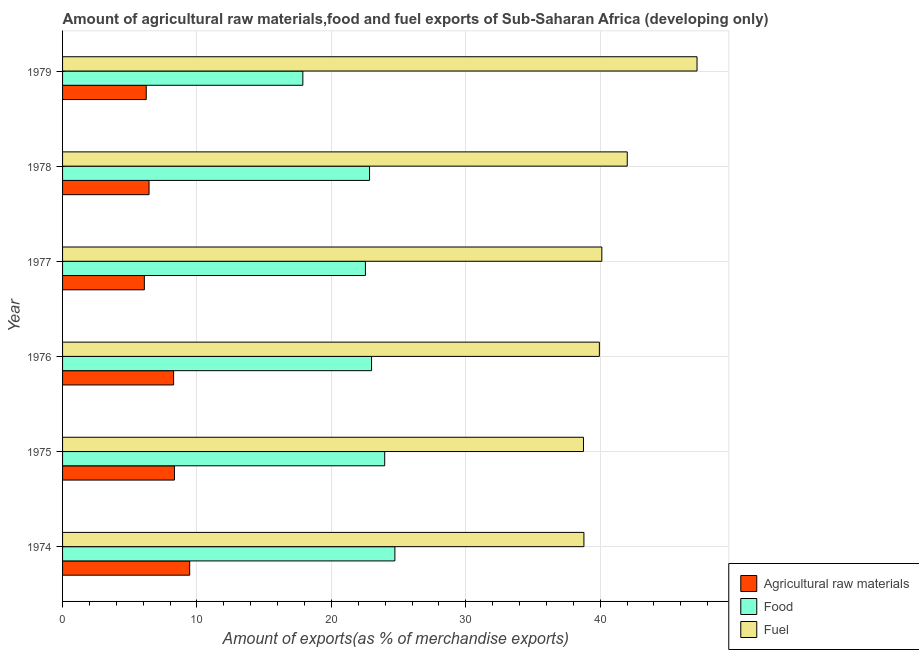How many groups of bars are there?
Your answer should be very brief. 6. Are the number of bars on each tick of the Y-axis equal?
Provide a short and direct response. Yes. How many bars are there on the 1st tick from the top?
Offer a very short reply. 3. What is the label of the 2nd group of bars from the top?
Offer a very short reply. 1978. In how many cases, is the number of bars for a given year not equal to the number of legend labels?
Your answer should be compact. 0. What is the percentage of raw materials exports in 1977?
Make the answer very short. 6.09. Across all years, what is the maximum percentage of raw materials exports?
Your response must be concise. 9.46. Across all years, what is the minimum percentage of raw materials exports?
Keep it short and to the point. 6.09. In which year was the percentage of raw materials exports maximum?
Keep it short and to the point. 1974. In which year was the percentage of food exports minimum?
Your answer should be very brief. 1979. What is the total percentage of food exports in the graph?
Make the answer very short. 134.93. What is the difference between the percentage of raw materials exports in 1976 and that in 1978?
Your answer should be very brief. 1.83. What is the difference between the percentage of food exports in 1979 and the percentage of fuel exports in 1977?
Make the answer very short. -22.24. What is the average percentage of food exports per year?
Your answer should be very brief. 22.49. In the year 1976, what is the difference between the percentage of fuel exports and percentage of food exports?
Offer a very short reply. 16.95. What is the ratio of the percentage of food exports in 1976 to that in 1977?
Make the answer very short. 1.02. Is the percentage of food exports in 1976 less than that in 1978?
Keep it short and to the point. No. What is the difference between the highest and the second highest percentage of food exports?
Offer a terse response. 0.76. What is the difference between the highest and the lowest percentage of fuel exports?
Ensure brevity in your answer.  8.45. In how many years, is the percentage of raw materials exports greater than the average percentage of raw materials exports taken over all years?
Your answer should be very brief. 3. Is the sum of the percentage of raw materials exports in 1978 and 1979 greater than the maximum percentage of food exports across all years?
Your answer should be very brief. No. What does the 1st bar from the top in 1977 represents?
Provide a short and direct response. Fuel. What does the 2nd bar from the bottom in 1976 represents?
Your answer should be very brief. Food. Is it the case that in every year, the sum of the percentage of raw materials exports and percentage of food exports is greater than the percentage of fuel exports?
Provide a short and direct response. No. How many bars are there?
Provide a succinct answer. 18. How many years are there in the graph?
Ensure brevity in your answer.  6. Are the values on the major ticks of X-axis written in scientific E-notation?
Your answer should be very brief. No. Does the graph contain grids?
Offer a very short reply. Yes. Where does the legend appear in the graph?
Provide a short and direct response. Bottom right. How many legend labels are there?
Give a very brief answer. 3. What is the title of the graph?
Keep it short and to the point. Amount of agricultural raw materials,food and fuel exports of Sub-Saharan Africa (developing only). What is the label or title of the X-axis?
Keep it short and to the point. Amount of exports(as % of merchandise exports). What is the Amount of exports(as % of merchandise exports) in Agricultural raw materials in 1974?
Give a very brief answer. 9.46. What is the Amount of exports(as % of merchandise exports) of Food in 1974?
Your response must be concise. 24.72. What is the Amount of exports(as % of merchandise exports) of Fuel in 1974?
Your answer should be compact. 38.79. What is the Amount of exports(as % of merchandise exports) of Agricultural raw materials in 1975?
Your answer should be very brief. 8.33. What is the Amount of exports(as % of merchandise exports) in Food in 1975?
Your response must be concise. 23.97. What is the Amount of exports(as % of merchandise exports) of Fuel in 1975?
Your answer should be very brief. 38.75. What is the Amount of exports(as % of merchandise exports) in Agricultural raw materials in 1976?
Offer a very short reply. 8.26. What is the Amount of exports(as % of merchandise exports) of Food in 1976?
Your answer should be compact. 22.99. What is the Amount of exports(as % of merchandise exports) of Fuel in 1976?
Offer a very short reply. 39.94. What is the Amount of exports(as % of merchandise exports) in Agricultural raw materials in 1977?
Your answer should be very brief. 6.09. What is the Amount of exports(as % of merchandise exports) in Food in 1977?
Ensure brevity in your answer.  22.53. What is the Amount of exports(as % of merchandise exports) in Fuel in 1977?
Provide a succinct answer. 40.12. What is the Amount of exports(as % of merchandise exports) in Agricultural raw materials in 1978?
Keep it short and to the point. 6.43. What is the Amount of exports(as % of merchandise exports) in Food in 1978?
Provide a short and direct response. 22.84. What is the Amount of exports(as % of merchandise exports) in Fuel in 1978?
Your answer should be very brief. 42.01. What is the Amount of exports(as % of merchandise exports) of Agricultural raw materials in 1979?
Your answer should be compact. 6.23. What is the Amount of exports(as % of merchandise exports) in Food in 1979?
Offer a very short reply. 17.88. What is the Amount of exports(as % of merchandise exports) of Fuel in 1979?
Your response must be concise. 47.2. Across all years, what is the maximum Amount of exports(as % of merchandise exports) of Agricultural raw materials?
Keep it short and to the point. 9.46. Across all years, what is the maximum Amount of exports(as % of merchandise exports) in Food?
Ensure brevity in your answer.  24.72. Across all years, what is the maximum Amount of exports(as % of merchandise exports) in Fuel?
Keep it short and to the point. 47.2. Across all years, what is the minimum Amount of exports(as % of merchandise exports) in Agricultural raw materials?
Your response must be concise. 6.09. Across all years, what is the minimum Amount of exports(as % of merchandise exports) in Food?
Keep it short and to the point. 17.88. Across all years, what is the minimum Amount of exports(as % of merchandise exports) of Fuel?
Your answer should be compact. 38.75. What is the total Amount of exports(as % of merchandise exports) in Agricultural raw materials in the graph?
Your answer should be compact. 44.79. What is the total Amount of exports(as % of merchandise exports) of Food in the graph?
Give a very brief answer. 134.93. What is the total Amount of exports(as % of merchandise exports) of Fuel in the graph?
Offer a terse response. 246.82. What is the difference between the Amount of exports(as % of merchandise exports) in Agricultural raw materials in 1974 and that in 1975?
Your answer should be very brief. 1.13. What is the difference between the Amount of exports(as % of merchandise exports) in Food in 1974 and that in 1975?
Make the answer very short. 0.76. What is the difference between the Amount of exports(as % of merchandise exports) in Fuel in 1974 and that in 1975?
Ensure brevity in your answer.  0.03. What is the difference between the Amount of exports(as % of merchandise exports) in Agricultural raw materials in 1974 and that in 1976?
Give a very brief answer. 1.2. What is the difference between the Amount of exports(as % of merchandise exports) in Food in 1974 and that in 1976?
Your response must be concise. 1.74. What is the difference between the Amount of exports(as % of merchandise exports) in Fuel in 1974 and that in 1976?
Offer a terse response. -1.15. What is the difference between the Amount of exports(as % of merchandise exports) of Agricultural raw materials in 1974 and that in 1977?
Offer a very short reply. 3.37. What is the difference between the Amount of exports(as % of merchandise exports) of Food in 1974 and that in 1977?
Keep it short and to the point. 2.19. What is the difference between the Amount of exports(as % of merchandise exports) in Fuel in 1974 and that in 1977?
Your answer should be compact. -1.33. What is the difference between the Amount of exports(as % of merchandise exports) in Agricultural raw materials in 1974 and that in 1978?
Make the answer very short. 3.02. What is the difference between the Amount of exports(as % of merchandise exports) of Food in 1974 and that in 1978?
Give a very brief answer. 1.89. What is the difference between the Amount of exports(as % of merchandise exports) of Fuel in 1974 and that in 1978?
Ensure brevity in your answer.  -3.22. What is the difference between the Amount of exports(as % of merchandise exports) of Agricultural raw materials in 1974 and that in 1979?
Give a very brief answer. 3.23. What is the difference between the Amount of exports(as % of merchandise exports) in Food in 1974 and that in 1979?
Offer a very short reply. 6.85. What is the difference between the Amount of exports(as % of merchandise exports) of Fuel in 1974 and that in 1979?
Your answer should be compact. -8.42. What is the difference between the Amount of exports(as % of merchandise exports) in Agricultural raw materials in 1975 and that in 1976?
Offer a very short reply. 0.06. What is the difference between the Amount of exports(as % of merchandise exports) in Food in 1975 and that in 1976?
Keep it short and to the point. 0.98. What is the difference between the Amount of exports(as % of merchandise exports) in Fuel in 1975 and that in 1976?
Provide a short and direct response. -1.18. What is the difference between the Amount of exports(as % of merchandise exports) of Agricultural raw materials in 1975 and that in 1977?
Your response must be concise. 2.24. What is the difference between the Amount of exports(as % of merchandise exports) in Food in 1975 and that in 1977?
Provide a short and direct response. 1.44. What is the difference between the Amount of exports(as % of merchandise exports) of Fuel in 1975 and that in 1977?
Offer a very short reply. -1.37. What is the difference between the Amount of exports(as % of merchandise exports) in Agricultural raw materials in 1975 and that in 1978?
Offer a very short reply. 1.89. What is the difference between the Amount of exports(as % of merchandise exports) of Food in 1975 and that in 1978?
Your response must be concise. 1.13. What is the difference between the Amount of exports(as % of merchandise exports) of Fuel in 1975 and that in 1978?
Make the answer very short. -3.26. What is the difference between the Amount of exports(as % of merchandise exports) in Agricultural raw materials in 1975 and that in 1979?
Your answer should be compact. 2.1. What is the difference between the Amount of exports(as % of merchandise exports) of Food in 1975 and that in 1979?
Your response must be concise. 6.09. What is the difference between the Amount of exports(as % of merchandise exports) of Fuel in 1975 and that in 1979?
Ensure brevity in your answer.  -8.45. What is the difference between the Amount of exports(as % of merchandise exports) of Agricultural raw materials in 1976 and that in 1977?
Provide a short and direct response. 2.18. What is the difference between the Amount of exports(as % of merchandise exports) in Food in 1976 and that in 1977?
Your answer should be very brief. 0.46. What is the difference between the Amount of exports(as % of merchandise exports) in Fuel in 1976 and that in 1977?
Offer a very short reply. -0.18. What is the difference between the Amount of exports(as % of merchandise exports) in Agricultural raw materials in 1976 and that in 1978?
Provide a short and direct response. 1.83. What is the difference between the Amount of exports(as % of merchandise exports) in Fuel in 1976 and that in 1978?
Provide a short and direct response. -2.07. What is the difference between the Amount of exports(as % of merchandise exports) of Agricultural raw materials in 1976 and that in 1979?
Ensure brevity in your answer.  2.04. What is the difference between the Amount of exports(as % of merchandise exports) in Food in 1976 and that in 1979?
Make the answer very short. 5.11. What is the difference between the Amount of exports(as % of merchandise exports) in Fuel in 1976 and that in 1979?
Ensure brevity in your answer.  -7.27. What is the difference between the Amount of exports(as % of merchandise exports) in Agricultural raw materials in 1977 and that in 1978?
Provide a short and direct response. -0.35. What is the difference between the Amount of exports(as % of merchandise exports) of Food in 1977 and that in 1978?
Provide a succinct answer. -0.31. What is the difference between the Amount of exports(as % of merchandise exports) of Fuel in 1977 and that in 1978?
Offer a terse response. -1.89. What is the difference between the Amount of exports(as % of merchandise exports) in Agricultural raw materials in 1977 and that in 1979?
Your response must be concise. -0.14. What is the difference between the Amount of exports(as % of merchandise exports) of Food in 1977 and that in 1979?
Ensure brevity in your answer.  4.66. What is the difference between the Amount of exports(as % of merchandise exports) of Fuel in 1977 and that in 1979?
Give a very brief answer. -7.08. What is the difference between the Amount of exports(as % of merchandise exports) in Agricultural raw materials in 1978 and that in 1979?
Your response must be concise. 0.21. What is the difference between the Amount of exports(as % of merchandise exports) of Food in 1978 and that in 1979?
Your answer should be compact. 4.96. What is the difference between the Amount of exports(as % of merchandise exports) in Fuel in 1978 and that in 1979?
Ensure brevity in your answer.  -5.19. What is the difference between the Amount of exports(as % of merchandise exports) in Agricultural raw materials in 1974 and the Amount of exports(as % of merchandise exports) in Food in 1975?
Offer a very short reply. -14.51. What is the difference between the Amount of exports(as % of merchandise exports) in Agricultural raw materials in 1974 and the Amount of exports(as % of merchandise exports) in Fuel in 1975?
Ensure brevity in your answer.  -29.3. What is the difference between the Amount of exports(as % of merchandise exports) of Food in 1974 and the Amount of exports(as % of merchandise exports) of Fuel in 1975?
Offer a terse response. -14.03. What is the difference between the Amount of exports(as % of merchandise exports) of Agricultural raw materials in 1974 and the Amount of exports(as % of merchandise exports) of Food in 1976?
Your answer should be very brief. -13.53. What is the difference between the Amount of exports(as % of merchandise exports) in Agricultural raw materials in 1974 and the Amount of exports(as % of merchandise exports) in Fuel in 1976?
Your response must be concise. -30.48. What is the difference between the Amount of exports(as % of merchandise exports) of Food in 1974 and the Amount of exports(as % of merchandise exports) of Fuel in 1976?
Your response must be concise. -15.21. What is the difference between the Amount of exports(as % of merchandise exports) of Agricultural raw materials in 1974 and the Amount of exports(as % of merchandise exports) of Food in 1977?
Your answer should be compact. -13.07. What is the difference between the Amount of exports(as % of merchandise exports) in Agricultural raw materials in 1974 and the Amount of exports(as % of merchandise exports) in Fuel in 1977?
Offer a very short reply. -30.66. What is the difference between the Amount of exports(as % of merchandise exports) of Food in 1974 and the Amount of exports(as % of merchandise exports) of Fuel in 1977?
Offer a terse response. -15.4. What is the difference between the Amount of exports(as % of merchandise exports) of Agricultural raw materials in 1974 and the Amount of exports(as % of merchandise exports) of Food in 1978?
Ensure brevity in your answer.  -13.38. What is the difference between the Amount of exports(as % of merchandise exports) of Agricultural raw materials in 1974 and the Amount of exports(as % of merchandise exports) of Fuel in 1978?
Provide a succinct answer. -32.55. What is the difference between the Amount of exports(as % of merchandise exports) of Food in 1974 and the Amount of exports(as % of merchandise exports) of Fuel in 1978?
Your answer should be very brief. -17.29. What is the difference between the Amount of exports(as % of merchandise exports) in Agricultural raw materials in 1974 and the Amount of exports(as % of merchandise exports) in Food in 1979?
Your response must be concise. -8.42. What is the difference between the Amount of exports(as % of merchandise exports) in Agricultural raw materials in 1974 and the Amount of exports(as % of merchandise exports) in Fuel in 1979?
Keep it short and to the point. -37.75. What is the difference between the Amount of exports(as % of merchandise exports) of Food in 1974 and the Amount of exports(as % of merchandise exports) of Fuel in 1979?
Offer a terse response. -22.48. What is the difference between the Amount of exports(as % of merchandise exports) in Agricultural raw materials in 1975 and the Amount of exports(as % of merchandise exports) in Food in 1976?
Ensure brevity in your answer.  -14.66. What is the difference between the Amount of exports(as % of merchandise exports) of Agricultural raw materials in 1975 and the Amount of exports(as % of merchandise exports) of Fuel in 1976?
Provide a short and direct response. -31.61. What is the difference between the Amount of exports(as % of merchandise exports) in Food in 1975 and the Amount of exports(as % of merchandise exports) in Fuel in 1976?
Keep it short and to the point. -15.97. What is the difference between the Amount of exports(as % of merchandise exports) in Agricultural raw materials in 1975 and the Amount of exports(as % of merchandise exports) in Food in 1977?
Provide a succinct answer. -14.21. What is the difference between the Amount of exports(as % of merchandise exports) in Agricultural raw materials in 1975 and the Amount of exports(as % of merchandise exports) in Fuel in 1977?
Give a very brief answer. -31.8. What is the difference between the Amount of exports(as % of merchandise exports) of Food in 1975 and the Amount of exports(as % of merchandise exports) of Fuel in 1977?
Give a very brief answer. -16.15. What is the difference between the Amount of exports(as % of merchandise exports) of Agricultural raw materials in 1975 and the Amount of exports(as % of merchandise exports) of Food in 1978?
Provide a short and direct response. -14.51. What is the difference between the Amount of exports(as % of merchandise exports) in Agricultural raw materials in 1975 and the Amount of exports(as % of merchandise exports) in Fuel in 1978?
Your answer should be very brief. -33.69. What is the difference between the Amount of exports(as % of merchandise exports) of Food in 1975 and the Amount of exports(as % of merchandise exports) of Fuel in 1978?
Offer a very short reply. -18.04. What is the difference between the Amount of exports(as % of merchandise exports) of Agricultural raw materials in 1975 and the Amount of exports(as % of merchandise exports) of Food in 1979?
Ensure brevity in your answer.  -9.55. What is the difference between the Amount of exports(as % of merchandise exports) in Agricultural raw materials in 1975 and the Amount of exports(as % of merchandise exports) in Fuel in 1979?
Provide a short and direct response. -38.88. What is the difference between the Amount of exports(as % of merchandise exports) of Food in 1975 and the Amount of exports(as % of merchandise exports) of Fuel in 1979?
Provide a succinct answer. -23.24. What is the difference between the Amount of exports(as % of merchandise exports) in Agricultural raw materials in 1976 and the Amount of exports(as % of merchandise exports) in Food in 1977?
Make the answer very short. -14.27. What is the difference between the Amount of exports(as % of merchandise exports) of Agricultural raw materials in 1976 and the Amount of exports(as % of merchandise exports) of Fuel in 1977?
Your answer should be compact. -31.86. What is the difference between the Amount of exports(as % of merchandise exports) in Food in 1976 and the Amount of exports(as % of merchandise exports) in Fuel in 1977?
Your response must be concise. -17.13. What is the difference between the Amount of exports(as % of merchandise exports) of Agricultural raw materials in 1976 and the Amount of exports(as % of merchandise exports) of Food in 1978?
Your answer should be compact. -14.58. What is the difference between the Amount of exports(as % of merchandise exports) of Agricultural raw materials in 1976 and the Amount of exports(as % of merchandise exports) of Fuel in 1978?
Give a very brief answer. -33.75. What is the difference between the Amount of exports(as % of merchandise exports) in Food in 1976 and the Amount of exports(as % of merchandise exports) in Fuel in 1978?
Your answer should be very brief. -19.02. What is the difference between the Amount of exports(as % of merchandise exports) of Agricultural raw materials in 1976 and the Amount of exports(as % of merchandise exports) of Food in 1979?
Offer a very short reply. -9.61. What is the difference between the Amount of exports(as % of merchandise exports) in Agricultural raw materials in 1976 and the Amount of exports(as % of merchandise exports) in Fuel in 1979?
Give a very brief answer. -38.94. What is the difference between the Amount of exports(as % of merchandise exports) of Food in 1976 and the Amount of exports(as % of merchandise exports) of Fuel in 1979?
Provide a short and direct response. -24.22. What is the difference between the Amount of exports(as % of merchandise exports) in Agricultural raw materials in 1977 and the Amount of exports(as % of merchandise exports) in Food in 1978?
Provide a succinct answer. -16.75. What is the difference between the Amount of exports(as % of merchandise exports) in Agricultural raw materials in 1977 and the Amount of exports(as % of merchandise exports) in Fuel in 1978?
Make the answer very short. -35.93. What is the difference between the Amount of exports(as % of merchandise exports) of Food in 1977 and the Amount of exports(as % of merchandise exports) of Fuel in 1978?
Ensure brevity in your answer.  -19.48. What is the difference between the Amount of exports(as % of merchandise exports) in Agricultural raw materials in 1977 and the Amount of exports(as % of merchandise exports) in Food in 1979?
Provide a short and direct response. -11.79. What is the difference between the Amount of exports(as % of merchandise exports) of Agricultural raw materials in 1977 and the Amount of exports(as % of merchandise exports) of Fuel in 1979?
Give a very brief answer. -41.12. What is the difference between the Amount of exports(as % of merchandise exports) of Food in 1977 and the Amount of exports(as % of merchandise exports) of Fuel in 1979?
Offer a very short reply. -24.67. What is the difference between the Amount of exports(as % of merchandise exports) of Agricultural raw materials in 1978 and the Amount of exports(as % of merchandise exports) of Food in 1979?
Ensure brevity in your answer.  -11.44. What is the difference between the Amount of exports(as % of merchandise exports) in Agricultural raw materials in 1978 and the Amount of exports(as % of merchandise exports) in Fuel in 1979?
Your answer should be compact. -40.77. What is the difference between the Amount of exports(as % of merchandise exports) in Food in 1978 and the Amount of exports(as % of merchandise exports) in Fuel in 1979?
Give a very brief answer. -24.37. What is the average Amount of exports(as % of merchandise exports) of Agricultural raw materials per year?
Give a very brief answer. 7.47. What is the average Amount of exports(as % of merchandise exports) of Food per year?
Give a very brief answer. 22.49. What is the average Amount of exports(as % of merchandise exports) in Fuel per year?
Provide a short and direct response. 41.14. In the year 1974, what is the difference between the Amount of exports(as % of merchandise exports) in Agricultural raw materials and Amount of exports(as % of merchandise exports) in Food?
Provide a succinct answer. -15.27. In the year 1974, what is the difference between the Amount of exports(as % of merchandise exports) of Agricultural raw materials and Amount of exports(as % of merchandise exports) of Fuel?
Make the answer very short. -29.33. In the year 1974, what is the difference between the Amount of exports(as % of merchandise exports) of Food and Amount of exports(as % of merchandise exports) of Fuel?
Your answer should be very brief. -14.06. In the year 1975, what is the difference between the Amount of exports(as % of merchandise exports) of Agricultural raw materials and Amount of exports(as % of merchandise exports) of Food?
Ensure brevity in your answer.  -15.64. In the year 1975, what is the difference between the Amount of exports(as % of merchandise exports) in Agricultural raw materials and Amount of exports(as % of merchandise exports) in Fuel?
Make the answer very short. -30.43. In the year 1975, what is the difference between the Amount of exports(as % of merchandise exports) of Food and Amount of exports(as % of merchandise exports) of Fuel?
Offer a very short reply. -14.79. In the year 1976, what is the difference between the Amount of exports(as % of merchandise exports) in Agricultural raw materials and Amount of exports(as % of merchandise exports) in Food?
Make the answer very short. -14.73. In the year 1976, what is the difference between the Amount of exports(as % of merchandise exports) of Agricultural raw materials and Amount of exports(as % of merchandise exports) of Fuel?
Give a very brief answer. -31.68. In the year 1976, what is the difference between the Amount of exports(as % of merchandise exports) in Food and Amount of exports(as % of merchandise exports) in Fuel?
Your answer should be compact. -16.95. In the year 1977, what is the difference between the Amount of exports(as % of merchandise exports) in Agricultural raw materials and Amount of exports(as % of merchandise exports) in Food?
Give a very brief answer. -16.45. In the year 1977, what is the difference between the Amount of exports(as % of merchandise exports) of Agricultural raw materials and Amount of exports(as % of merchandise exports) of Fuel?
Offer a terse response. -34.04. In the year 1977, what is the difference between the Amount of exports(as % of merchandise exports) in Food and Amount of exports(as % of merchandise exports) in Fuel?
Your answer should be very brief. -17.59. In the year 1978, what is the difference between the Amount of exports(as % of merchandise exports) of Agricultural raw materials and Amount of exports(as % of merchandise exports) of Food?
Offer a terse response. -16.4. In the year 1978, what is the difference between the Amount of exports(as % of merchandise exports) in Agricultural raw materials and Amount of exports(as % of merchandise exports) in Fuel?
Offer a very short reply. -35.58. In the year 1978, what is the difference between the Amount of exports(as % of merchandise exports) in Food and Amount of exports(as % of merchandise exports) in Fuel?
Your answer should be very brief. -19.17. In the year 1979, what is the difference between the Amount of exports(as % of merchandise exports) in Agricultural raw materials and Amount of exports(as % of merchandise exports) in Food?
Your answer should be compact. -11.65. In the year 1979, what is the difference between the Amount of exports(as % of merchandise exports) in Agricultural raw materials and Amount of exports(as % of merchandise exports) in Fuel?
Keep it short and to the point. -40.98. In the year 1979, what is the difference between the Amount of exports(as % of merchandise exports) in Food and Amount of exports(as % of merchandise exports) in Fuel?
Your answer should be compact. -29.33. What is the ratio of the Amount of exports(as % of merchandise exports) in Agricultural raw materials in 1974 to that in 1975?
Give a very brief answer. 1.14. What is the ratio of the Amount of exports(as % of merchandise exports) in Food in 1974 to that in 1975?
Your response must be concise. 1.03. What is the ratio of the Amount of exports(as % of merchandise exports) of Agricultural raw materials in 1974 to that in 1976?
Offer a very short reply. 1.14. What is the ratio of the Amount of exports(as % of merchandise exports) in Food in 1974 to that in 1976?
Ensure brevity in your answer.  1.08. What is the ratio of the Amount of exports(as % of merchandise exports) of Fuel in 1974 to that in 1976?
Provide a short and direct response. 0.97. What is the ratio of the Amount of exports(as % of merchandise exports) of Agricultural raw materials in 1974 to that in 1977?
Offer a very short reply. 1.55. What is the ratio of the Amount of exports(as % of merchandise exports) of Food in 1974 to that in 1977?
Provide a short and direct response. 1.1. What is the ratio of the Amount of exports(as % of merchandise exports) in Fuel in 1974 to that in 1977?
Offer a terse response. 0.97. What is the ratio of the Amount of exports(as % of merchandise exports) in Agricultural raw materials in 1974 to that in 1978?
Ensure brevity in your answer.  1.47. What is the ratio of the Amount of exports(as % of merchandise exports) in Food in 1974 to that in 1978?
Give a very brief answer. 1.08. What is the ratio of the Amount of exports(as % of merchandise exports) of Fuel in 1974 to that in 1978?
Provide a succinct answer. 0.92. What is the ratio of the Amount of exports(as % of merchandise exports) of Agricultural raw materials in 1974 to that in 1979?
Your response must be concise. 1.52. What is the ratio of the Amount of exports(as % of merchandise exports) of Food in 1974 to that in 1979?
Offer a very short reply. 1.38. What is the ratio of the Amount of exports(as % of merchandise exports) in Fuel in 1974 to that in 1979?
Offer a very short reply. 0.82. What is the ratio of the Amount of exports(as % of merchandise exports) in Agricultural raw materials in 1975 to that in 1976?
Offer a very short reply. 1.01. What is the ratio of the Amount of exports(as % of merchandise exports) in Food in 1975 to that in 1976?
Ensure brevity in your answer.  1.04. What is the ratio of the Amount of exports(as % of merchandise exports) of Fuel in 1975 to that in 1976?
Make the answer very short. 0.97. What is the ratio of the Amount of exports(as % of merchandise exports) of Agricultural raw materials in 1975 to that in 1977?
Keep it short and to the point. 1.37. What is the ratio of the Amount of exports(as % of merchandise exports) in Food in 1975 to that in 1977?
Offer a very short reply. 1.06. What is the ratio of the Amount of exports(as % of merchandise exports) in Fuel in 1975 to that in 1977?
Your answer should be compact. 0.97. What is the ratio of the Amount of exports(as % of merchandise exports) in Agricultural raw materials in 1975 to that in 1978?
Your answer should be compact. 1.29. What is the ratio of the Amount of exports(as % of merchandise exports) of Food in 1975 to that in 1978?
Your answer should be very brief. 1.05. What is the ratio of the Amount of exports(as % of merchandise exports) of Fuel in 1975 to that in 1978?
Provide a succinct answer. 0.92. What is the ratio of the Amount of exports(as % of merchandise exports) in Agricultural raw materials in 1975 to that in 1979?
Keep it short and to the point. 1.34. What is the ratio of the Amount of exports(as % of merchandise exports) of Food in 1975 to that in 1979?
Give a very brief answer. 1.34. What is the ratio of the Amount of exports(as % of merchandise exports) in Fuel in 1975 to that in 1979?
Offer a very short reply. 0.82. What is the ratio of the Amount of exports(as % of merchandise exports) in Agricultural raw materials in 1976 to that in 1977?
Keep it short and to the point. 1.36. What is the ratio of the Amount of exports(as % of merchandise exports) of Food in 1976 to that in 1977?
Your response must be concise. 1.02. What is the ratio of the Amount of exports(as % of merchandise exports) in Agricultural raw materials in 1976 to that in 1978?
Your answer should be very brief. 1.28. What is the ratio of the Amount of exports(as % of merchandise exports) of Food in 1976 to that in 1978?
Provide a short and direct response. 1.01. What is the ratio of the Amount of exports(as % of merchandise exports) in Fuel in 1976 to that in 1978?
Provide a succinct answer. 0.95. What is the ratio of the Amount of exports(as % of merchandise exports) of Agricultural raw materials in 1976 to that in 1979?
Offer a very short reply. 1.33. What is the ratio of the Amount of exports(as % of merchandise exports) of Food in 1976 to that in 1979?
Your answer should be very brief. 1.29. What is the ratio of the Amount of exports(as % of merchandise exports) of Fuel in 1976 to that in 1979?
Your response must be concise. 0.85. What is the ratio of the Amount of exports(as % of merchandise exports) of Agricultural raw materials in 1977 to that in 1978?
Provide a succinct answer. 0.95. What is the ratio of the Amount of exports(as % of merchandise exports) in Food in 1977 to that in 1978?
Give a very brief answer. 0.99. What is the ratio of the Amount of exports(as % of merchandise exports) of Fuel in 1977 to that in 1978?
Your response must be concise. 0.95. What is the ratio of the Amount of exports(as % of merchandise exports) in Agricultural raw materials in 1977 to that in 1979?
Ensure brevity in your answer.  0.98. What is the ratio of the Amount of exports(as % of merchandise exports) in Food in 1977 to that in 1979?
Make the answer very short. 1.26. What is the ratio of the Amount of exports(as % of merchandise exports) of Fuel in 1977 to that in 1979?
Offer a terse response. 0.85. What is the ratio of the Amount of exports(as % of merchandise exports) in Agricultural raw materials in 1978 to that in 1979?
Give a very brief answer. 1.03. What is the ratio of the Amount of exports(as % of merchandise exports) in Food in 1978 to that in 1979?
Keep it short and to the point. 1.28. What is the ratio of the Amount of exports(as % of merchandise exports) in Fuel in 1978 to that in 1979?
Provide a succinct answer. 0.89. What is the difference between the highest and the second highest Amount of exports(as % of merchandise exports) of Agricultural raw materials?
Ensure brevity in your answer.  1.13. What is the difference between the highest and the second highest Amount of exports(as % of merchandise exports) in Food?
Your response must be concise. 0.76. What is the difference between the highest and the second highest Amount of exports(as % of merchandise exports) of Fuel?
Offer a terse response. 5.19. What is the difference between the highest and the lowest Amount of exports(as % of merchandise exports) in Agricultural raw materials?
Your response must be concise. 3.37. What is the difference between the highest and the lowest Amount of exports(as % of merchandise exports) of Food?
Provide a succinct answer. 6.85. What is the difference between the highest and the lowest Amount of exports(as % of merchandise exports) in Fuel?
Provide a short and direct response. 8.45. 